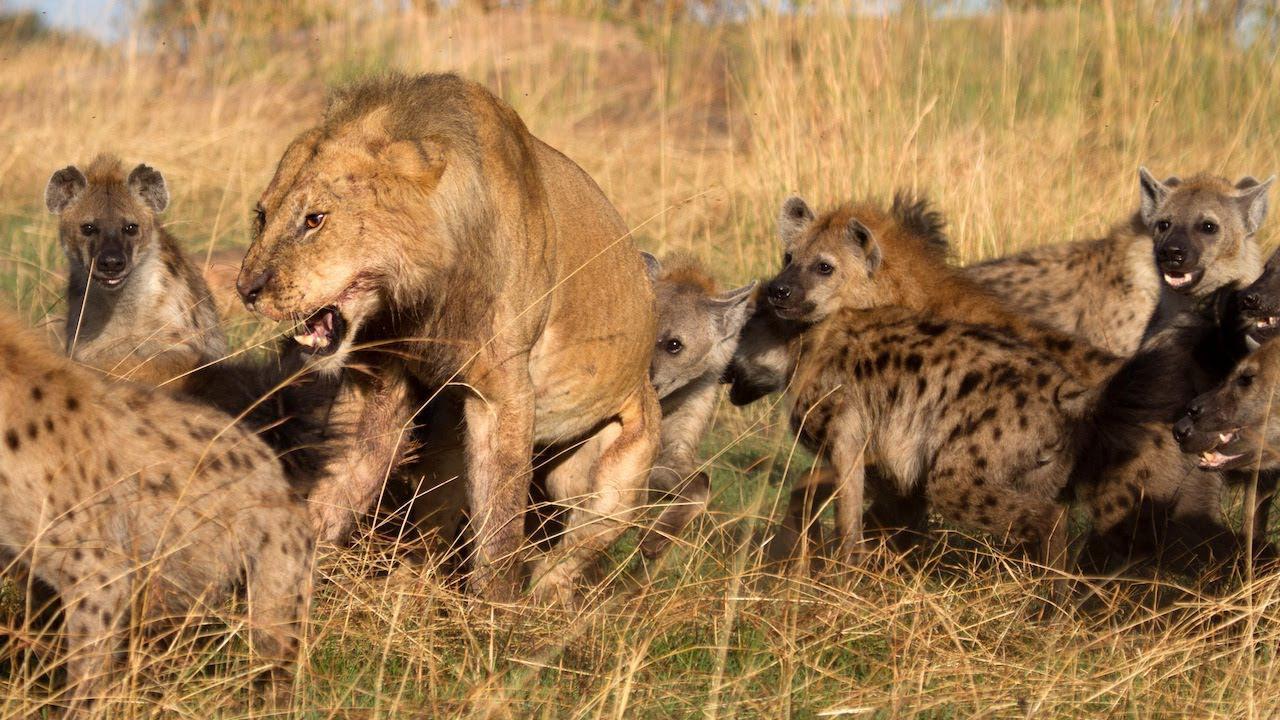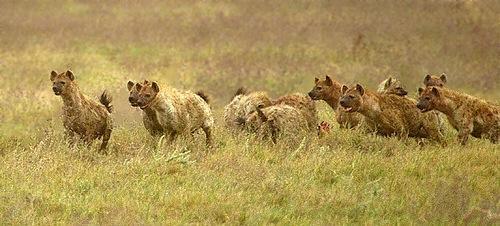The first image is the image on the left, the second image is the image on the right. For the images displayed, is the sentence "Right image shows a close grouping of no more than five hyenas." factually correct? Answer yes or no. No. The first image is the image on the left, the second image is the image on the right. Evaluate the accuracy of this statement regarding the images: "There are no more than 4 hyenas in one of the images". Is it true? Answer yes or no. No. 